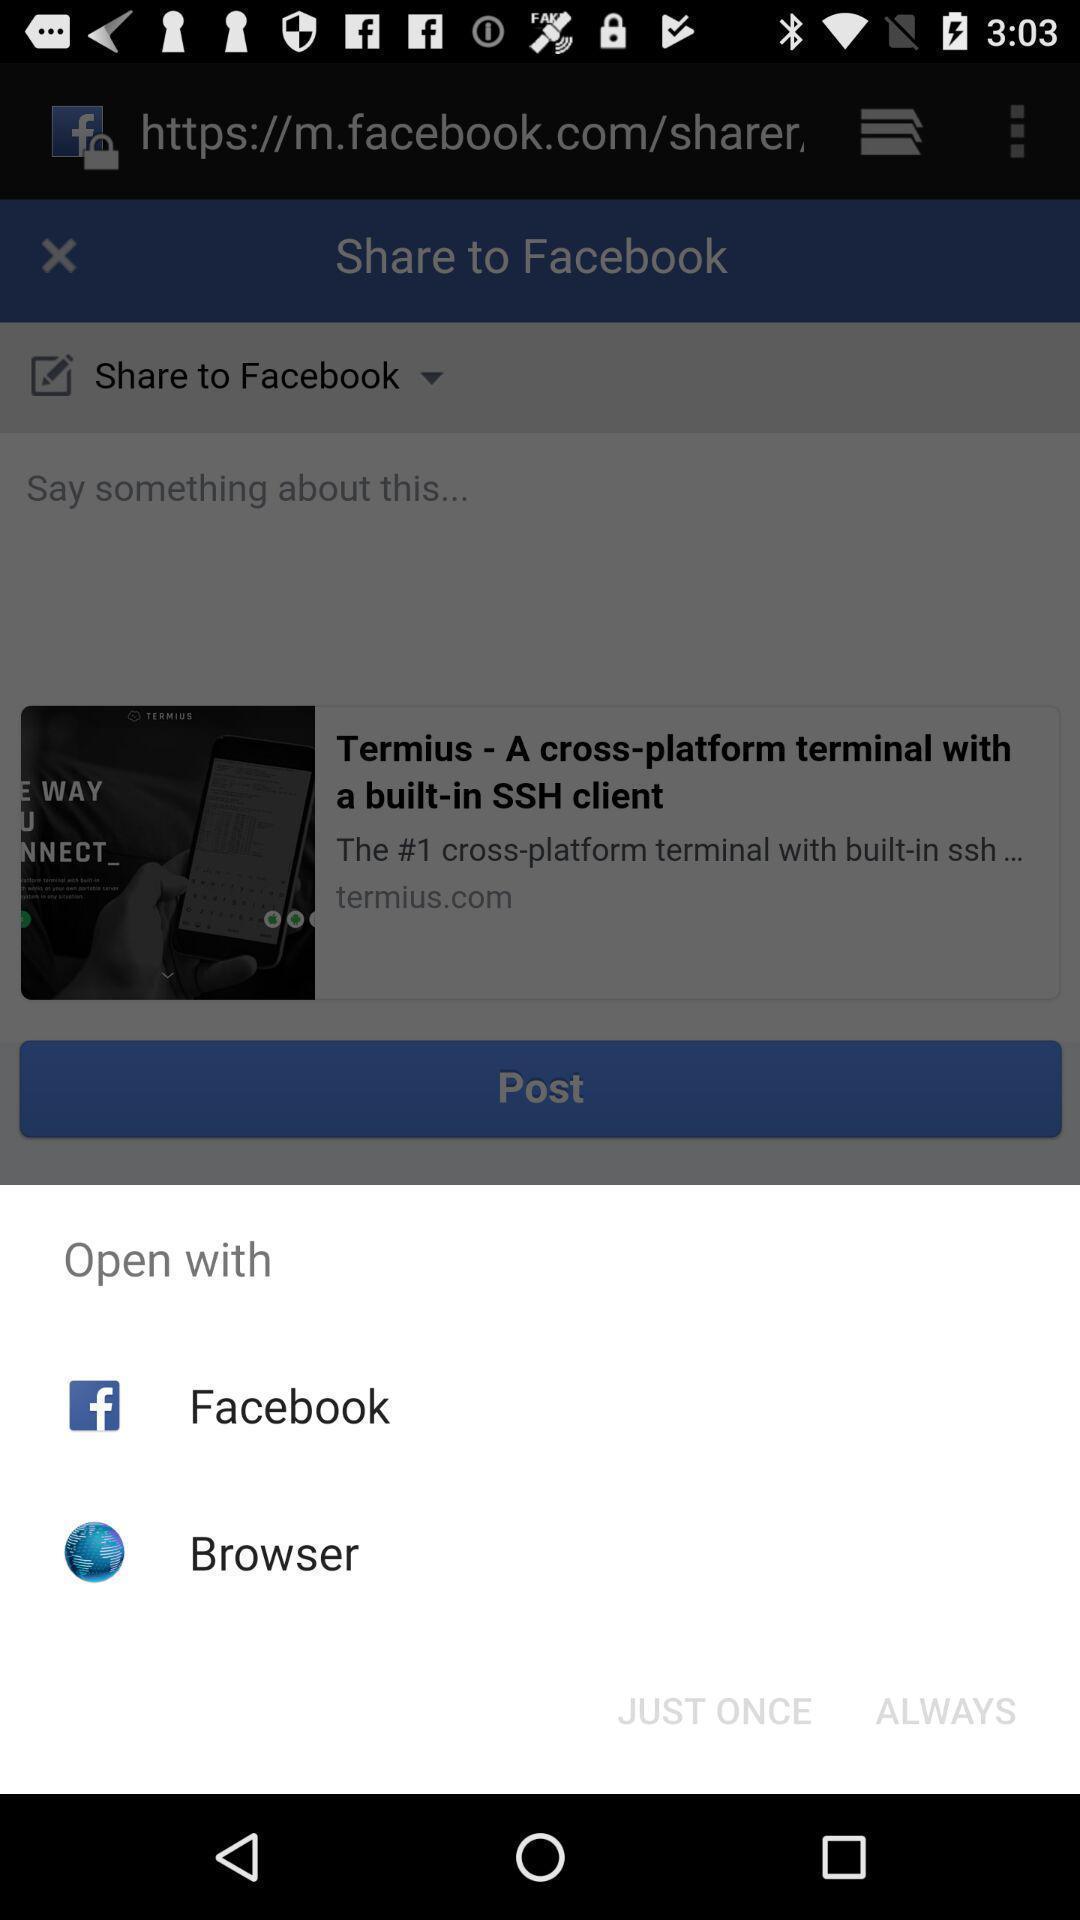Tell me about the visual elements in this screen capture. Pop-up showing multiple apps to open. 